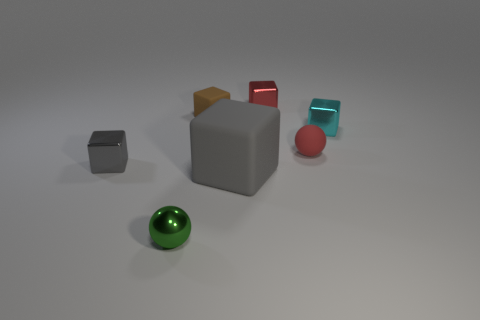Is there any other thing that is the same size as the gray matte thing?
Offer a very short reply. No. What material is the brown object left of the tiny ball behind the gray thing left of the shiny sphere?
Give a very brief answer. Rubber. Are there more green rubber cubes than blocks?
Offer a terse response. No. Is there any other thing of the same color as the metal sphere?
Give a very brief answer. No. There is a cyan thing that is the same material as the small gray thing; what is its size?
Your response must be concise. Small. What material is the green object?
Ensure brevity in your answer.  Metal. What number of red rubber balls are the same size as the brown object?
Give a very brief answer. 1. There is a tiny object that is the same color as the large matte object; what is its shape?
Your answer should be compact. Cube. Is there a green metal thing that has the same shape as the brown object?
Your response must be concise. No. What color is the rubber cube that is the same size as the cyan metallic thing?
Your response must be concise. Brown. 